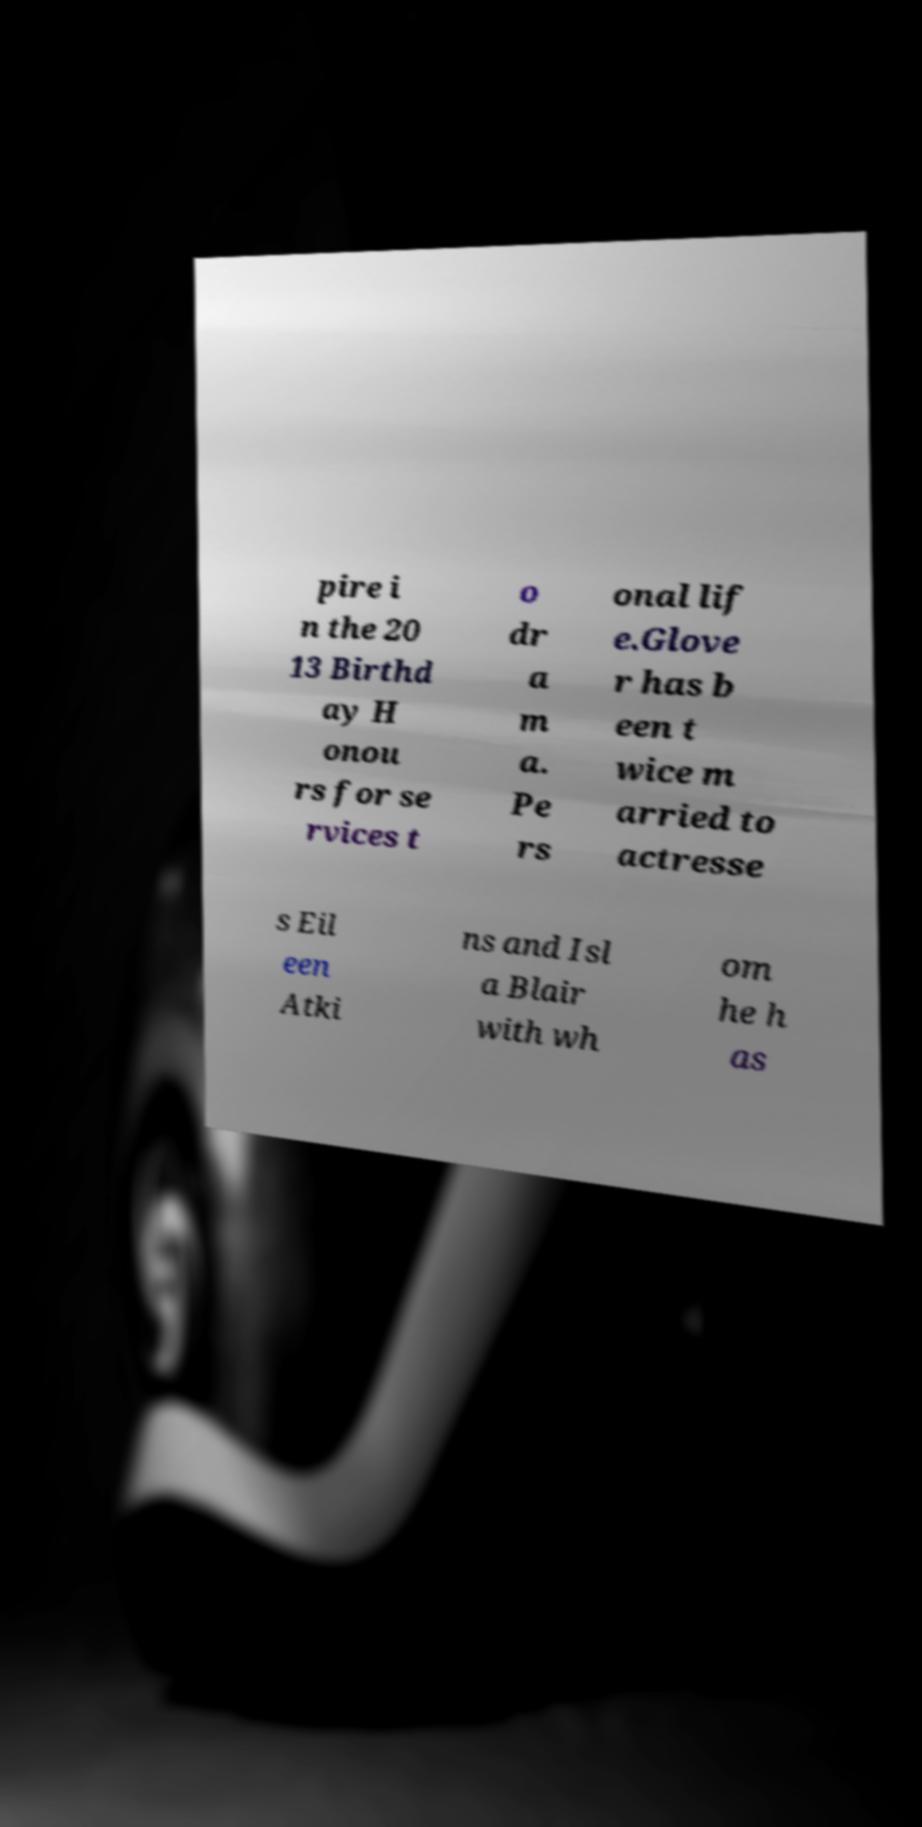Could you assist in decoding the text presented in this image and type it out clearly? pire i n the 20 13 Birthd ay H onou rs for se rvices t o dr a m a. Pe rs onal lif e.Glove r has b een t wice m arried to actresse s Eil een Atki ns and Isl a Blair with wh om he h as 